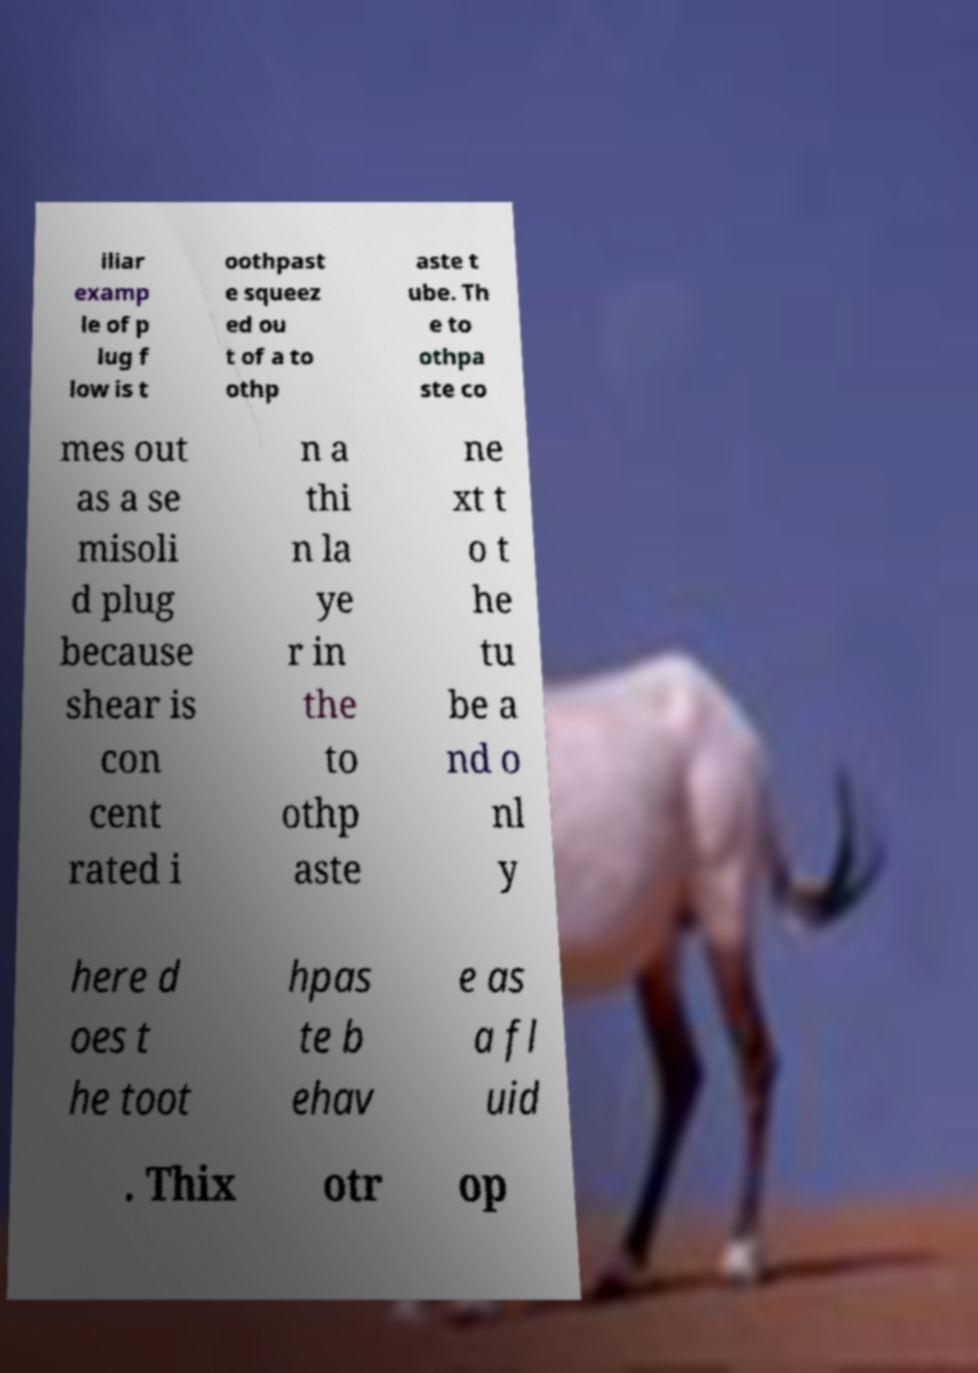For documentation purposes, I need the text within this image transcribed. Could you provide that? iliar examp le of p lug f low is t oothpast e squeez ed ou t of a to othp aste t ube. Th e to othpa ste co mes out as a se misoli d plug because shear is con cent rated i n a thi n la ye r in the to othp aste ne xt t o t he tu be a nd o nl y here d oes t he toot hpas te b ehav e as a fl uid . Thix otr op 